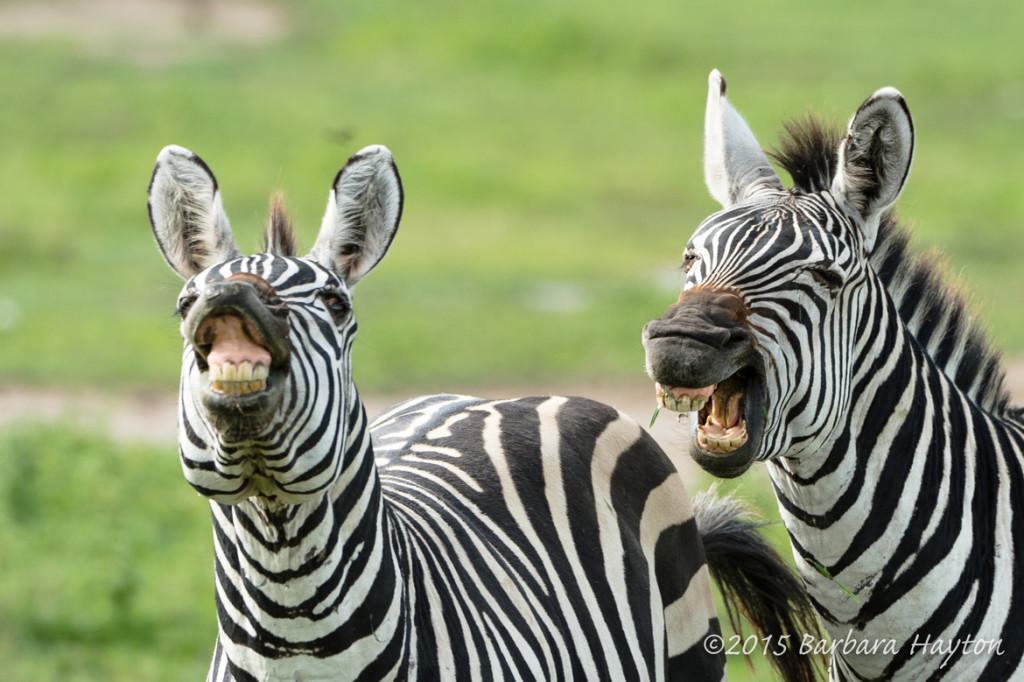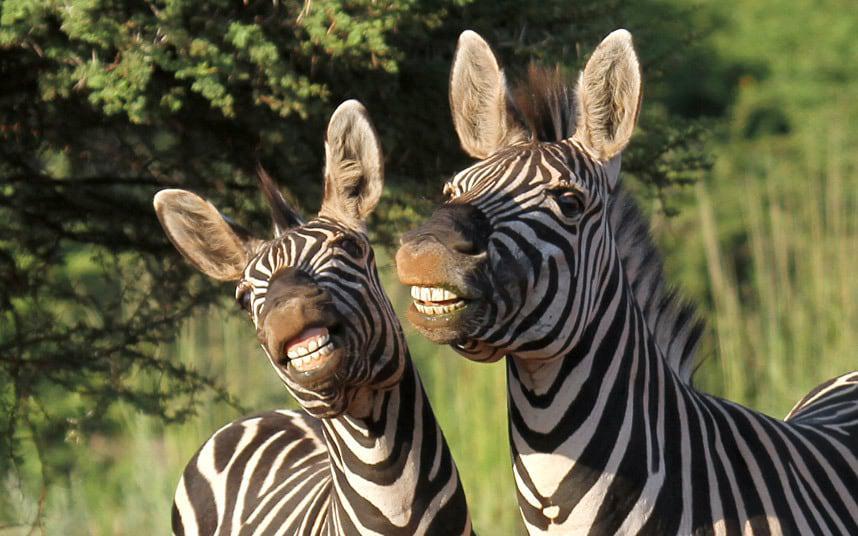The first image is the image on the left, the second image is the image on the right. Considering the images on both sides, is "All zebras are showing their teeth as if braying, and at least one image features two zebras side-by-side." valid? Answer yes or no. Yes. The first image is the image on the left, the second image is the image on the right. Analyze the images presented: Is the assertion "There are at least four zebras in total." valid? Answer yes or no. Yes. 